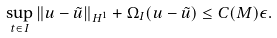Convert formula to latex. <formula><loc_0><loc_0><loc_500><loc_500>\sup _ { t \in I } \| u - \tilde { u } \| _ { H ^ { 1 } } + \Omega _ { I } ( u - \tilde { u } ) \leq C ( M ) \epsilon .</formula> 